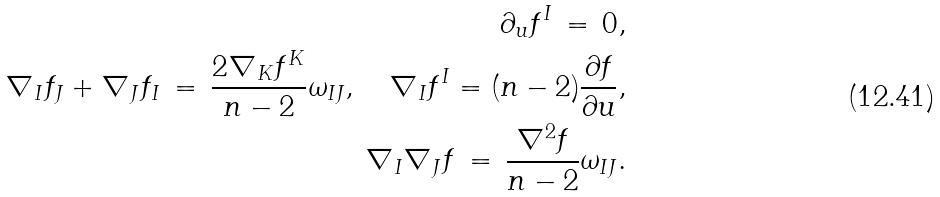Convert formula to latex. <formula><loc_0><loc_0><loc_500><loc_500>\partial _ { u } f ^ { I } \, = \, 0 , \\ \nabla _ { I } f _ { J } + \nabla _ { J } f _ { I } \, = \, \frac { 2 \nabla _ { K } f ^ { K } } { n - 2 } \omega _ { I J } , \quad \nabla _ { I } f ^ { I } = ( n - 2 ) \frac { \partial f } { \partial u } , \\ \nabla _ { I } \nabla _ { J } f \, = \, \frac { \nabla ^ { 2 } f } { n - 2 } \omega _ { I J } .</formula> 